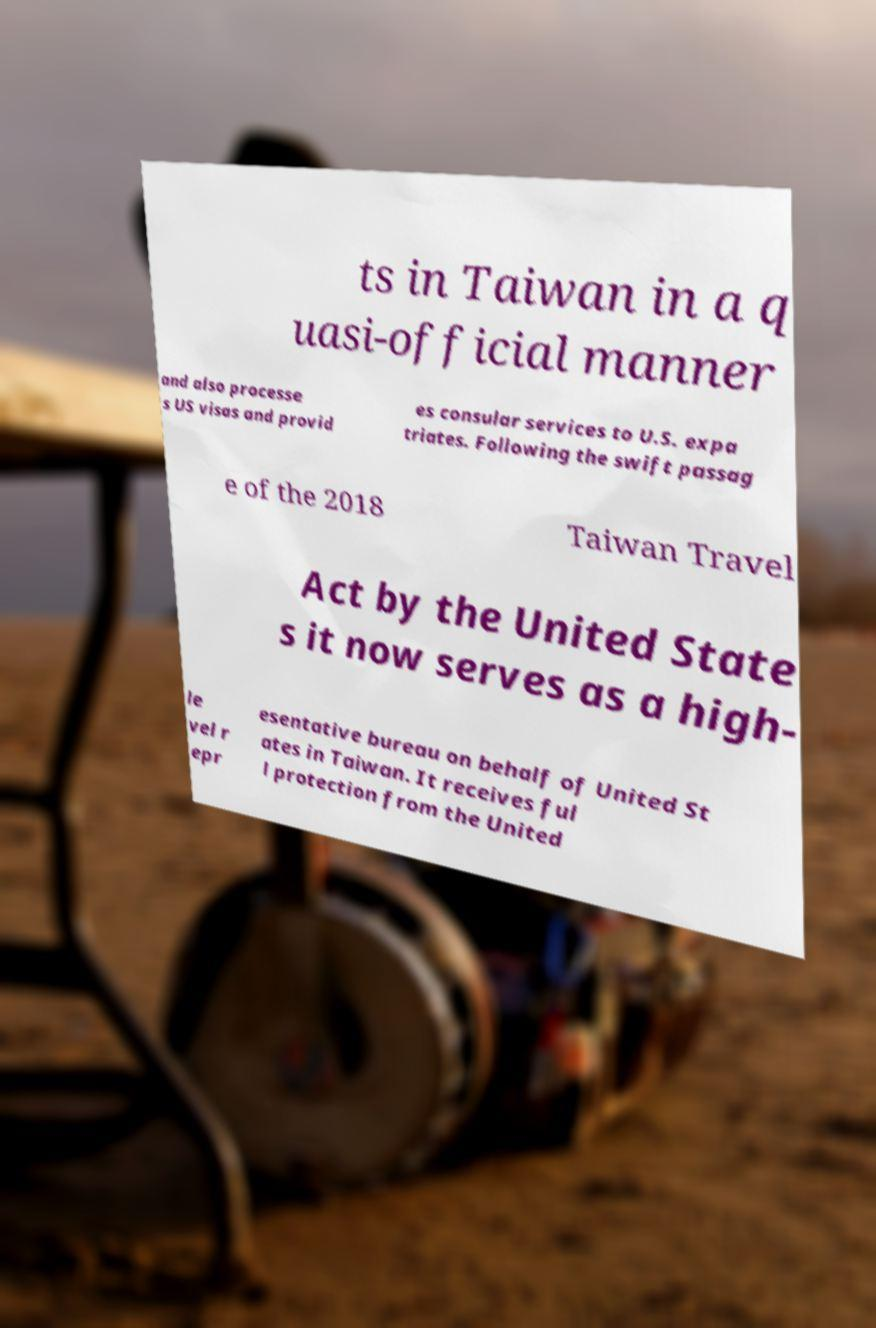I need the written content from this picture converted into text. Can you do that? ts in Taiwan in a q uasi-official manner and also processe s US visas and provid es consular services to U.S. expa triates. Following the swift passag e of the 2018 Taiwan Travel Act by the United State s it now serves as a high- le vel r epr esentative bureau on behalf of United St ates in Taiwan. It receives ful l protection from the United 